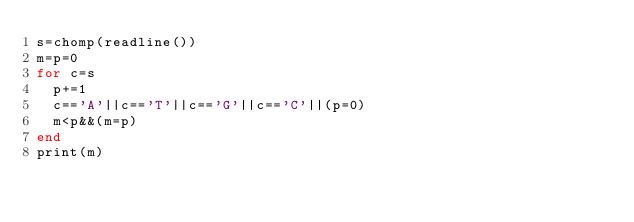Convert code to text. <code><loc_0><loc_0><loc_500><loc_500><_Julia_>s=chomp(readline())
m=p=0
for c=s
  p+=1
  c=='A'||c=='T'||c=='G'||c=='C'||(p=0)
  m<p&&(m=p)
end
print(m)</code> 